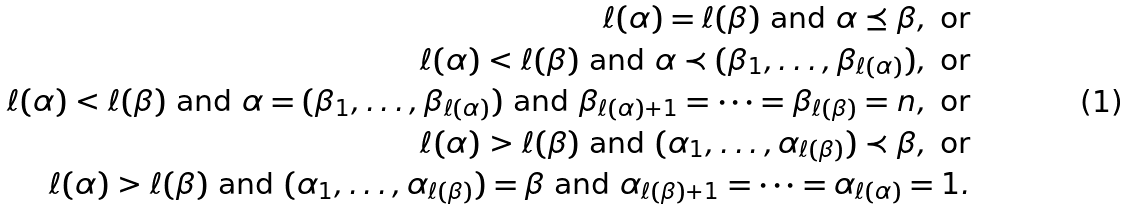Convert formula to latex. <formula><loc_0><loc_0><loc_500><loc_500>\ell ( \alpha ) = \ell ( \beta ) \text { and } \alpha \preceq \beta , \text { or} \\ \ell ( \alpha ) < \ell ( \beta ) \text { and } \alpha \prec ( \beta _ { 1 } , \dots , \beta _ { \ell ( \alpha ) } ) , \text { or} \\ \ell ( \alpha ) < \ell ( \beta ) \text { and } \alpha = ( \beta _ { 1 } , \dots , \beta _ { \ell ( \alpha ) } ) \text { and } \beta _ { \ell ( \alpha ) + 1 } = \dots = \beta _ { \ell ( \beta ) } = n , \text { or} \\ \ell ( \alpha ) > \ell ( \beta ) \text { and } ( \alpha _ { 1 } , \dots , \alpha _ { \ell ( \beta ) } ) \prec \beta , \text { or} \\ \ell ( \alpha ) > \ell ( \beta ) \text { and } ( \alpha _ { 1 } , \dots , \alpha _ { \ell ( \beta ) } ) = \beta \text { and } \alpha _ { \ell ( \beta ) + 1 } = \dots = \alpha _ { \ell ( \alpha ) } = 1 .</formula> 